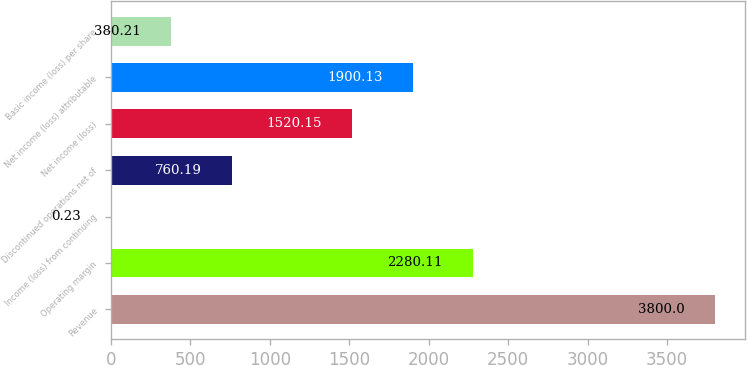Convert chart to OTSL. <chart><loc_0><loc_0><loc_500><loc_500><bar_chart><fcel>Revenue<fcel>Operating margin<fcel>Income (loss) from continuing<fcel>Discontinued operations net of<fcel>Net income (loss)<fcel>Net income (loss) attributable<fcel>Basic income (loss) per share<nl><fcel>3800<fcel>2280.11<fcel>0.23<fcel>760.19<fcel>1520.15<fcel>1900.13<fcel>380.21<nl></chart> 